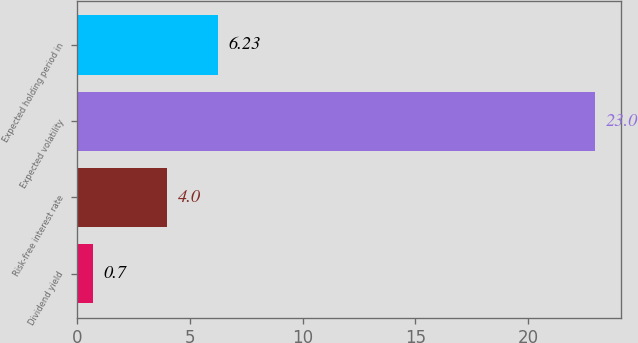Convert chart. <chart><loc_0><loc_0><loc_500><loc_500><bar_chart><fcel>Dividend yield<fcel>Risk-free interest rate<fcel>Expected volatility<fcel>Expected holding period in<nl><fcel>0.7<fcel>4<fcel>23<fcel>6.23<nl></chart> 